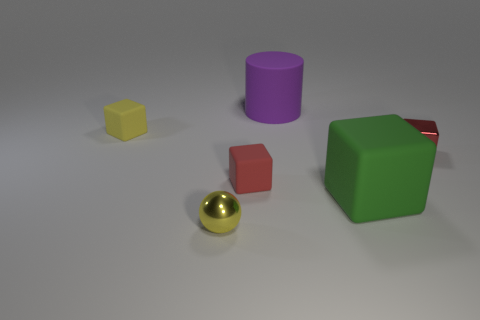What number of small rubber blocks are on the left side of the object in front of the large rubber object that is in front of the small red rubber cube?
Offer a terse response. 1. What size is the red matte object that is the same shape as the large green matte object?
Your response must be concise. Small. Is there any other thing that is the same size as the purple cylinder?
Your answer should be compact. Yes. Are there fewer small balls right of the red matte block than red metal objects?
Make the answer very short. Yes. Do the tiny yellow matte object and the purple rubber object have the same shape?
Ensure brevity in your answer.  No. There is another big thing that is the same shape as the red rubber object; what is its color?
Offer a terse response. Green. How many cubes are the same color as the tiny metal sphere?
Keep it short and to the point. 1. How many things are yellow objects that are left of the small metallic sphere or tiny green objects?
Give a very brief answer. 1. What is the size of the metallic thing on the left side of the red rubber cube?
Provide a succinct answer. Small. Are there fewer blue matte cylinders than small yellow spheres?
Provide a succinct answer. Yes. 